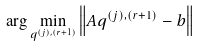Convert formula to latex. <formula><loc_0><loc_0><loc_500><loc_500>\arg \min _ { q ^ { ( j ) , ( r + 1 ) } } \left \| A q ^ { ( j ) , ( r + 1 ) } - b \right \|</formula> 